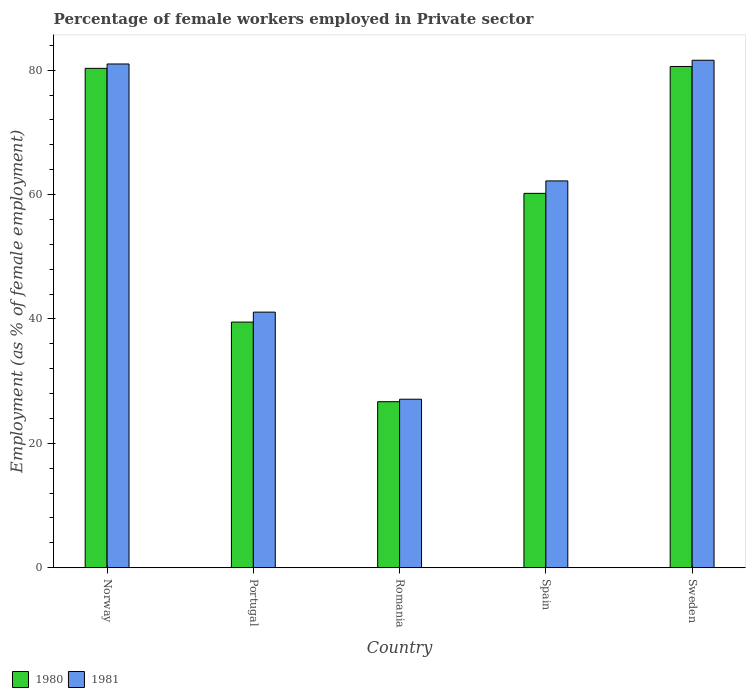Are the number of bars per tick equal to the number of legend labels?
Provide a succinct answer. Yes. Are the number of bars on each tick of the X-axis equal?
Make the answer very short. Yes. In how many cases, is the number of bars for a given country not equal to the number of legend labels?
Provide a short and direct response. 0. What is the percentage of females employed in Private sector in 1980 in Portugal?
Your response must be concise. 39.5. Across all countries, what is the maximum percentage of females employed in Private sector in 1981?
Provide a succinct answer. 81.6. Across all countries, what is the minimum percentage of females employed in Private sector in 1980?
Make the answer very short. 26.7. In which country was the percentage of females employed in Private sector in 1980 maximum?
Give a very brief answer. Sweden. In which country was the percentage of females employed in Private sector in 1981 minimum?
Offer a terse response. Romania. What is the total percentage of females employed in Private sector in 1981 in the graph?
Your answer should be compact. 293. What is the difference between the percentage of females employed in Private sector in 1980 in Norway and that in Portugal?
Provide a succinct answer. 40.8. What is the difference between the percentage of females employed in Private sector in 1981 in Norway and the percentage of females employed in Private sector in 1980 in Spain?
Keep it short and to the point. 20.8. What is the average percentage of females employed in Private sector in 1980 per country?
Your answer should be very brief. 57.46. In how many countries, is the percentage of females employed in Private sector in 1980 greater than 16 %?
Give a very brief answer. 5. What is the ratio of the percentage of females employed in Private sector in 1980 in Spain to that in Sweden?
Your answer should be compact. 0.75. Is the percentage of females employed in Private sector in 1981 in Portugal less than that in Sweden?
Offer a very short reply. Yes. What is the difference between the highest and the second highest percentage of females employed in Private sector in 1981?
Offer a terse response. -0.6. What is the difference between the highest and the lowest percentage of females employed in Private sector in 1981?
Offer a terse response. 54.5. Is the sum of the percentage of females employed in Private sector in 1980 in Norway and Spain greater than the maximum percentage of females employed in Private sector in 1981 across all countries?
Ensure brevity in your answer.  Yes. What does the 2nd bar from the left in Spain represents?
Offer a very short reply. 1981. Does the graph contain any zero values?
Offer a very short reply. No. How many legend labels are there?
Your response must be concise. 2. How are the legend labels stacked?
Ensure brevity in your answer.  Horizontal. What is the title of the graph?
Your answer should be compact. Percentage of female workers employed in Private sector. Does "1982" appear as one of the legend labels in the graph?
Your response must be concise. No. What is the label or title of the X-axis?
Make the answer very short. Country. What is the label or title of the Y-axis?
Offer a terse response. Employment (as % of female employment). What is the Employment (as % of female employment) of 1980 in Norway?
Offer a very short reply. 80.3. What is the Employment (as % of female employment) in 1981 in Norway?
Offer a terse response. 81. What is the Employment (as % of female employment) of 1980 in Portugal?
Make the answer very short. 39.5. What is the Employment (as % of female employment) of 1981 in Portugal?
Your response must be concise. 41.1. What is the Employment (as % of female employment) in 1980 in Romania?
Give a very brief answer. 26.7. What is the Employment (as % of female employment) in 1981 in Romania?
Make the answer very short. 27.1. What is the Employment (as % of female employment) in 1980 in Spain?
Your answer should be compact. 60.2. What is the Employment (as % of female employment) of 1981 in Spain?
Keep it short and to the point. 62.2. What is the Employment (as % of female employment) in 1980 in Sweden?
Your response must be concise. 80.6. What is the Employment (as % of female employment) of 1981 in Sweden?
Your answer should be very brief. 81.6. Across all countries, what is the maximum Employment (as % of female employment) in 1980?
Offer a terse response. 80.6. Across all countries, what is the maximum Employment (as % of female employment) of 1981?
Your answer should be compact. 81.6. Across all countries, what is the minimum Employment (as % of female employment) of 1980?
Ensure brevity in your answer.  26.7. Across all countries, what is the minimum Employment (as % of female employment) in 1981?
Your response must be concise. 27.1. What is the total Employment (as % of female employment) in 1980 in the graph?
Provide a short and direct response. 287.3. What is the total Employment (as % of female employment) in 1981 in the graph?
Give a very brief answer. 293. What is the difference between the Employment (as % of female employment) in 1980 in Norway and that in Portugal?
Ensure brevity in your answer.  40.8. What is the difference between the Employment (as % of female employment) in 1981 in Norway and that in Portugal?
Your answer should be compact. 39.9. What is the difference between the Employment (as % of female employment) in 1980 in Norway and that in Romania?
Your answer should be compact. 53.6. What is the difference between the Employment (as % of female employment) of 1981 in Norway and that in Romania?
Your answer should be compact. 53.9. What is the difference between the Employment (as % of female employment) of 1980 in Norway and that in Spain?
Offer a terse response. 20.1. What is the difference between the Employment (as % of female employment) of 1981 in Norway and that in Spain?
Your answer should be compact. 18.8. What is the difference between the Employment (as % of female employment) in 1980 in Portugal and that in Romania?
Make the answer very short. 12.8. What is the difference between the Employment (as % of female employment) of 1981 in Portugal and that in Romania?
Offer a very short reply. 14. What is the difference between the Employment (as % of female employment) in 1980 in Portugal and that in Spain?
Give a very brief answer. -20.7. What is the difference between the Employment (as % of female employment) in 1981 in Portugal and that in Spain?
Your answer should be very brief. -21.1. What is the difference between the Employment (as % of female employment) of 1980 in Portugal and that in Sweden?
Your answer should be compact. -41.1. What is the difference between the Employment (as % of female employment) of 1981 in Portugal and that in Sweden?
Offer a very short reply. -40.5. What is the difference between the Employment (as % of female employment) in 1980 in Romania and that in Spain?
Provide a short and direct response. -33.5. What is the difference between the Employment (as % of female employment) in 1981 in Romania and that in Spain?
Ensure brevity in your answer.  -35.1. What is the difference between the Employment (as % of female employment) of 1980 in Romania and that in Sweden?
Your response must be concise. -53.9. What is the difference between the Employment (as % of female employment) of 1981 in Romania and that in Sweden?
Give a very brief answer. -54.5. What is the difference between the Employment (as % of female employment) in 1980 in Spain and that in Sweden?
Your answer should be very brief. -20.4. What is the difference between the Employment (as % of female employment) of 1981 in Spain and that in Sweden?
Give a very brief answer. -19.4. What is the difference between the Employment (as % of female employment) in 1980 in Norway and the Employment (as % of female employment) in 1981 in Portugal?
Your answer should be very brief. 39.2. What is the difference between the Employment (as % of female employment) in 1980 in Norway and the Employment (as % of female employment) in 1981 in Romania?
Provide a succinct answer. 53.2. What is the difference between the Employment (as % of female employment) in 1980 in Norway and the Employment (as % of female employment) in 1981 in Spain?
Provide a short and direct response. 18.1. What is the difference between the Employment (as % of female employment) of 1980 in Portugal and the Employment (as % of female employment) of 1981 in Romania?
Provide a short and direct response. 12.4. What is the difference between the Employment (as % of female employment) in 1980 in Portugal and the Employment (as % of female employment) in 1981 in Spain?
Give a very brief answer. -22.7. What is the difference between the Employment (as % of female employment) of 1980 in Portugal and the Employment (as % of female employment) of 1981 in Sweden?
Offer a very short reply. -42.1. What is the difference between the Employment (as % of female employment) of 1980 in Romania and the Employment (as % of female employment) of 1981 in Spain?
Offer a very short reply. -35.5. What is the difference between the Employment (as % of female employment) of 1980 in Romania and the Employment (as % of female employment) of 1981 in Sweden?
Your answer should be compact. -54.9. What is the difference between the Employment (as % of female employment) of 1980 in Spain and the Employment (as % of female employment) of 1981 in Sweden?
Your answer should be compact. -21.4. What is the average Employment (as % of female employment) of 1980 per country?
Provide a short and direct response. 57.46. What is the average Employment (as % of female employment) of 1981 per country?
Ensure brevity in your answer.  58.6. What is the difference between the Employment (as % of female employment) of 1980 and Employment (as % of female employment) of 1981 in Norway?
Offer a terse response. -0.7. What is the difference between the Employment (as % of female employment) of 1980 and Employment (as % of female employment) of 1981 in Spain?
Ensure brevity in your answer.  -2. What is the difference between the Employment (as % of female employment) in 1980 and Employment (as % of female employment) in 1981 in Sweden?
Your answer should be compact. -1. What is the ratio of the Employment (as % of female employment) in 1980 in Norway to that in Portugal?
Offer a very short reply. 2.03. What is the ratio of the Employment (as % of female employment) of 1981 in Norway to that in Portugal?
Ensure brevity in your answer.  1.97. What is the ratio of the Employment (as % of female employment) of 1980 in Norway to that in Romania?
Make the answer very short. 3.01. What is the ratio of the Employment (as % of female employment) of 1981 in Norway to that in Romania?
Your answer should be compact. 2.99. What is the ratio of the Employment (as % of female employment) in 1980 in Norway to that in Spain?
Your answer should be compact. 1.33. What is the ratio of the Employment (as % of female employment) in 1981 in Norway to that in Spain?
Give a very brief answer. 1.3. What is the ratio of the Employment (as % of female employment) of 1980 in Norway to that in Sweden?
Keep it short and to the point. 1. What is the ratio of the Employment (as % of female employment) in 1980 in Portugal to that in Romania?
Your answer should be very brief. 1.48. What is the ratio of the Employment (as % of female employment) in 1981 in Portugal to that in Romania?
Provide a succinct answer. 1.52. What is the ratio of the Employment (as % of female employment) of 1980 in Portugal to that in Spain?
Give a very brief answer. 0.66. What is the ratio of the Employment (as % of female employment) of 1981 in Portugal to that in Spain?
Provide a succinct answer. 0.66. What is the ratio of the Employment (as % of female employment) in 1980 in Portugal to that in Sweden?
Your response must be concise. 0.49. What is the ratio of the Employment (as % of female employment) of 1981 in Portugal to that in Sweden?
Provide a short and direct response. 0.5. What is the ratio of the Employment (as % of female employment) in 1980 in Romania to that in Spain?
Provide a succinct answer. 0.44. What is the ratio of the Employment (as % of female employment) in 1981 in Romania to that in Spain?
Offer a very short reply. 0.44. What is the ratio of the Employment (as % of female employment) of 1980 in Romania to that in Sweden?
Ensure brevity in your answer.  0.33. What is the ratio of the Employment (as % of female employment) in 1981 in Romania to that in Sweden?
Your answer should be very brief. 0.33. What is the ratio of the Employment (as % of female employment) in 1980 in Spain to that in Sweden?
Offer a very short reply. 0.75. What is the ratio of the Employment (as % of female employment) of 1981 in Spain to that in Sweden?
Offer a very short reply. 0.76. What is the difference between the highest and the second highest Employment (as % of female employment) of 1980?
Give a very brief answer. 0.3. What is the difference between the highest and the second highest Employment (as % of female employment) of 1981?
Offer a terse response. 0.6. What is the difference between the highest and the lowest Employment (as % of female employment) in 1980?
Ensure brevity in your answer.  53.9. What is the difference between the highest and the lowest Employment (as % of female employment) in 1981?
Give a very brief answer. 54.5. 